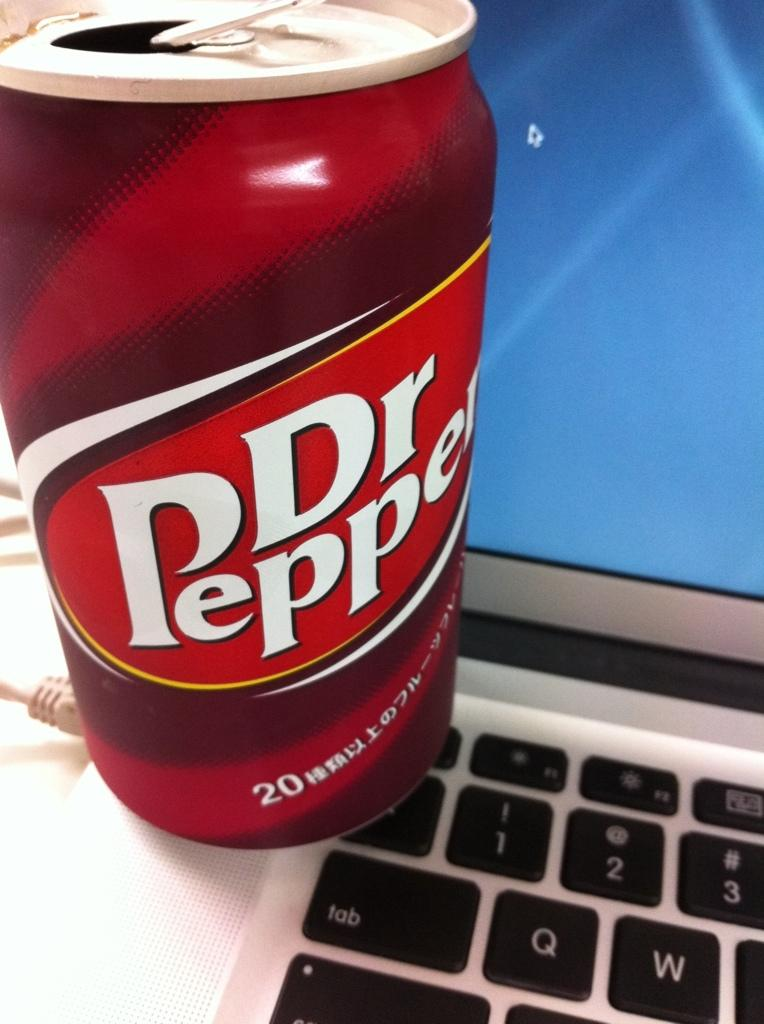<image>
Relay a brief, clear account of the picture shown. a bottle of dr pepper and a laptop computer 